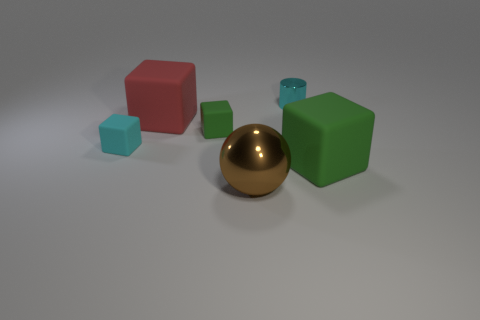The large matte cube behind the small green block is what color?
Provide a succinct answer. Red. There is a big matte block behind the cube that is right of the shiny ball; is there a tiny thing to the left of it?
Your answer should be very brief. Yes. Is the number of metal things that are in front of the cyan cube greater than the number of big red matte cylinders?
Offer a very short reply. Yes. Does the tiny cyan object to the right of the small green matte block have the same shape as the red thing?
Offer a very short reply. No. Is there any other thing that has the same material as the large sphere?
Make the answer very short. Yes. How many objects are either big green matte cubes or large blocks that are in front of the red object?
Give a very brief answer. 1. What size is the object that is both behind the tiny green rubber block and on the left side of the brown metal thing?
Your response must be concise. Large. Is the number of small objects that are behind the tiny metal cylinder greater than the number of cyan things to the right of the large brown metallic object?
Ensure brevity in your answer.  No. Is the shape of the brown shiny object the same as the green object to the right of the brown object?
Keep it short and to the point. No. How many other objects are there of the same shape as the cyan shiny thing?
Offer a terse response. 0. 